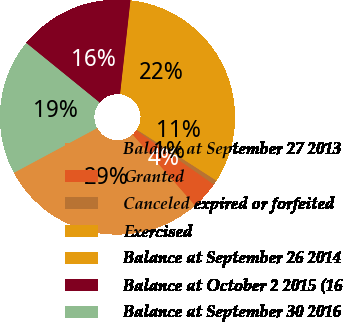<chart> <loc_0><loc_0><loc_500><loc_500><pie_chart><fcel>Balance at September 27 2013<fcel>Granted<fcel>Canceled expired or forfeited<fcel>Exercised<fcel>Balance at September 26 2014<fcel>Balance at October 2 2015 (16<fcel>Balance at September 30 2016<nl><fcel>28.63%<fcel>3.82%<fcel>0.64%<fcel>10.81%<fcel>21.5%<fcel>15.9%<fcel>18.7%<nl></chart> 